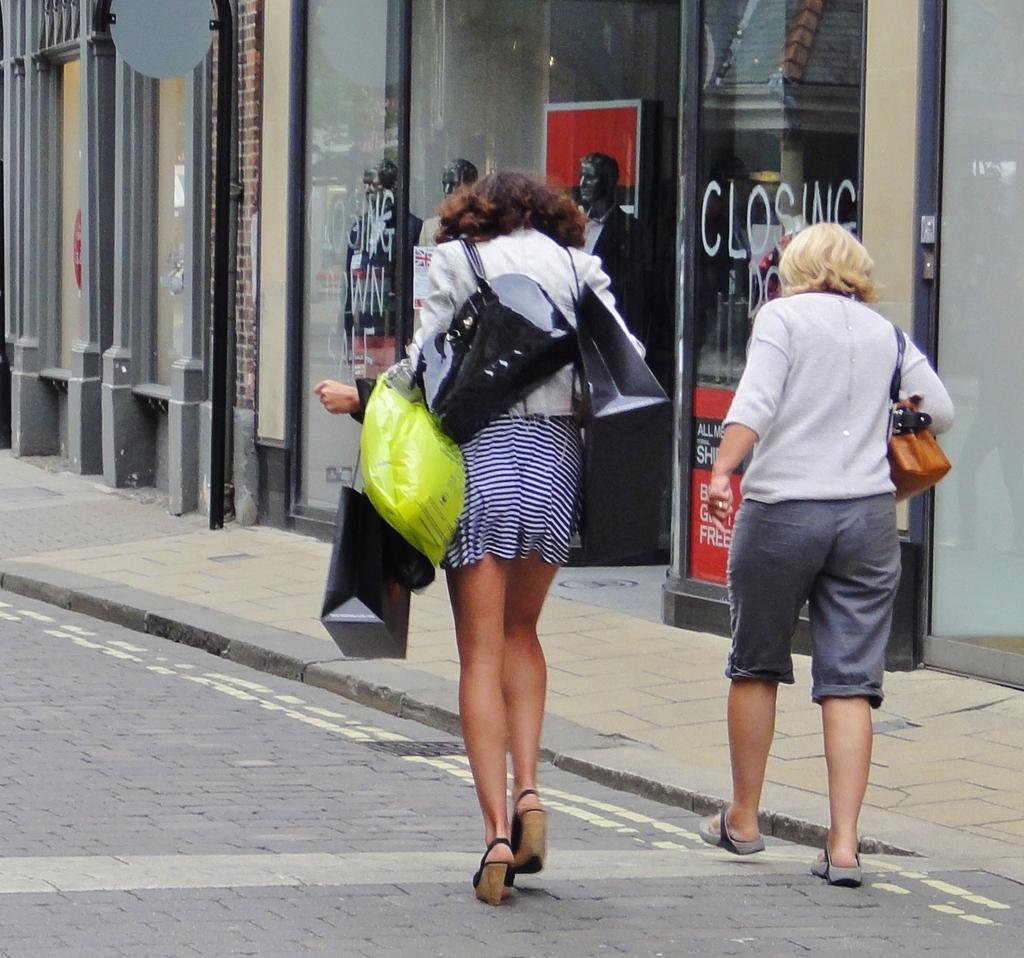Can you describe this image briefly? In this image we can see one building, three dolls wearing dresses in the shop, some text on the shop glass door, one footpath, one pole, two women walking on the road wearing bags and one woman with black hair holding some objects. 